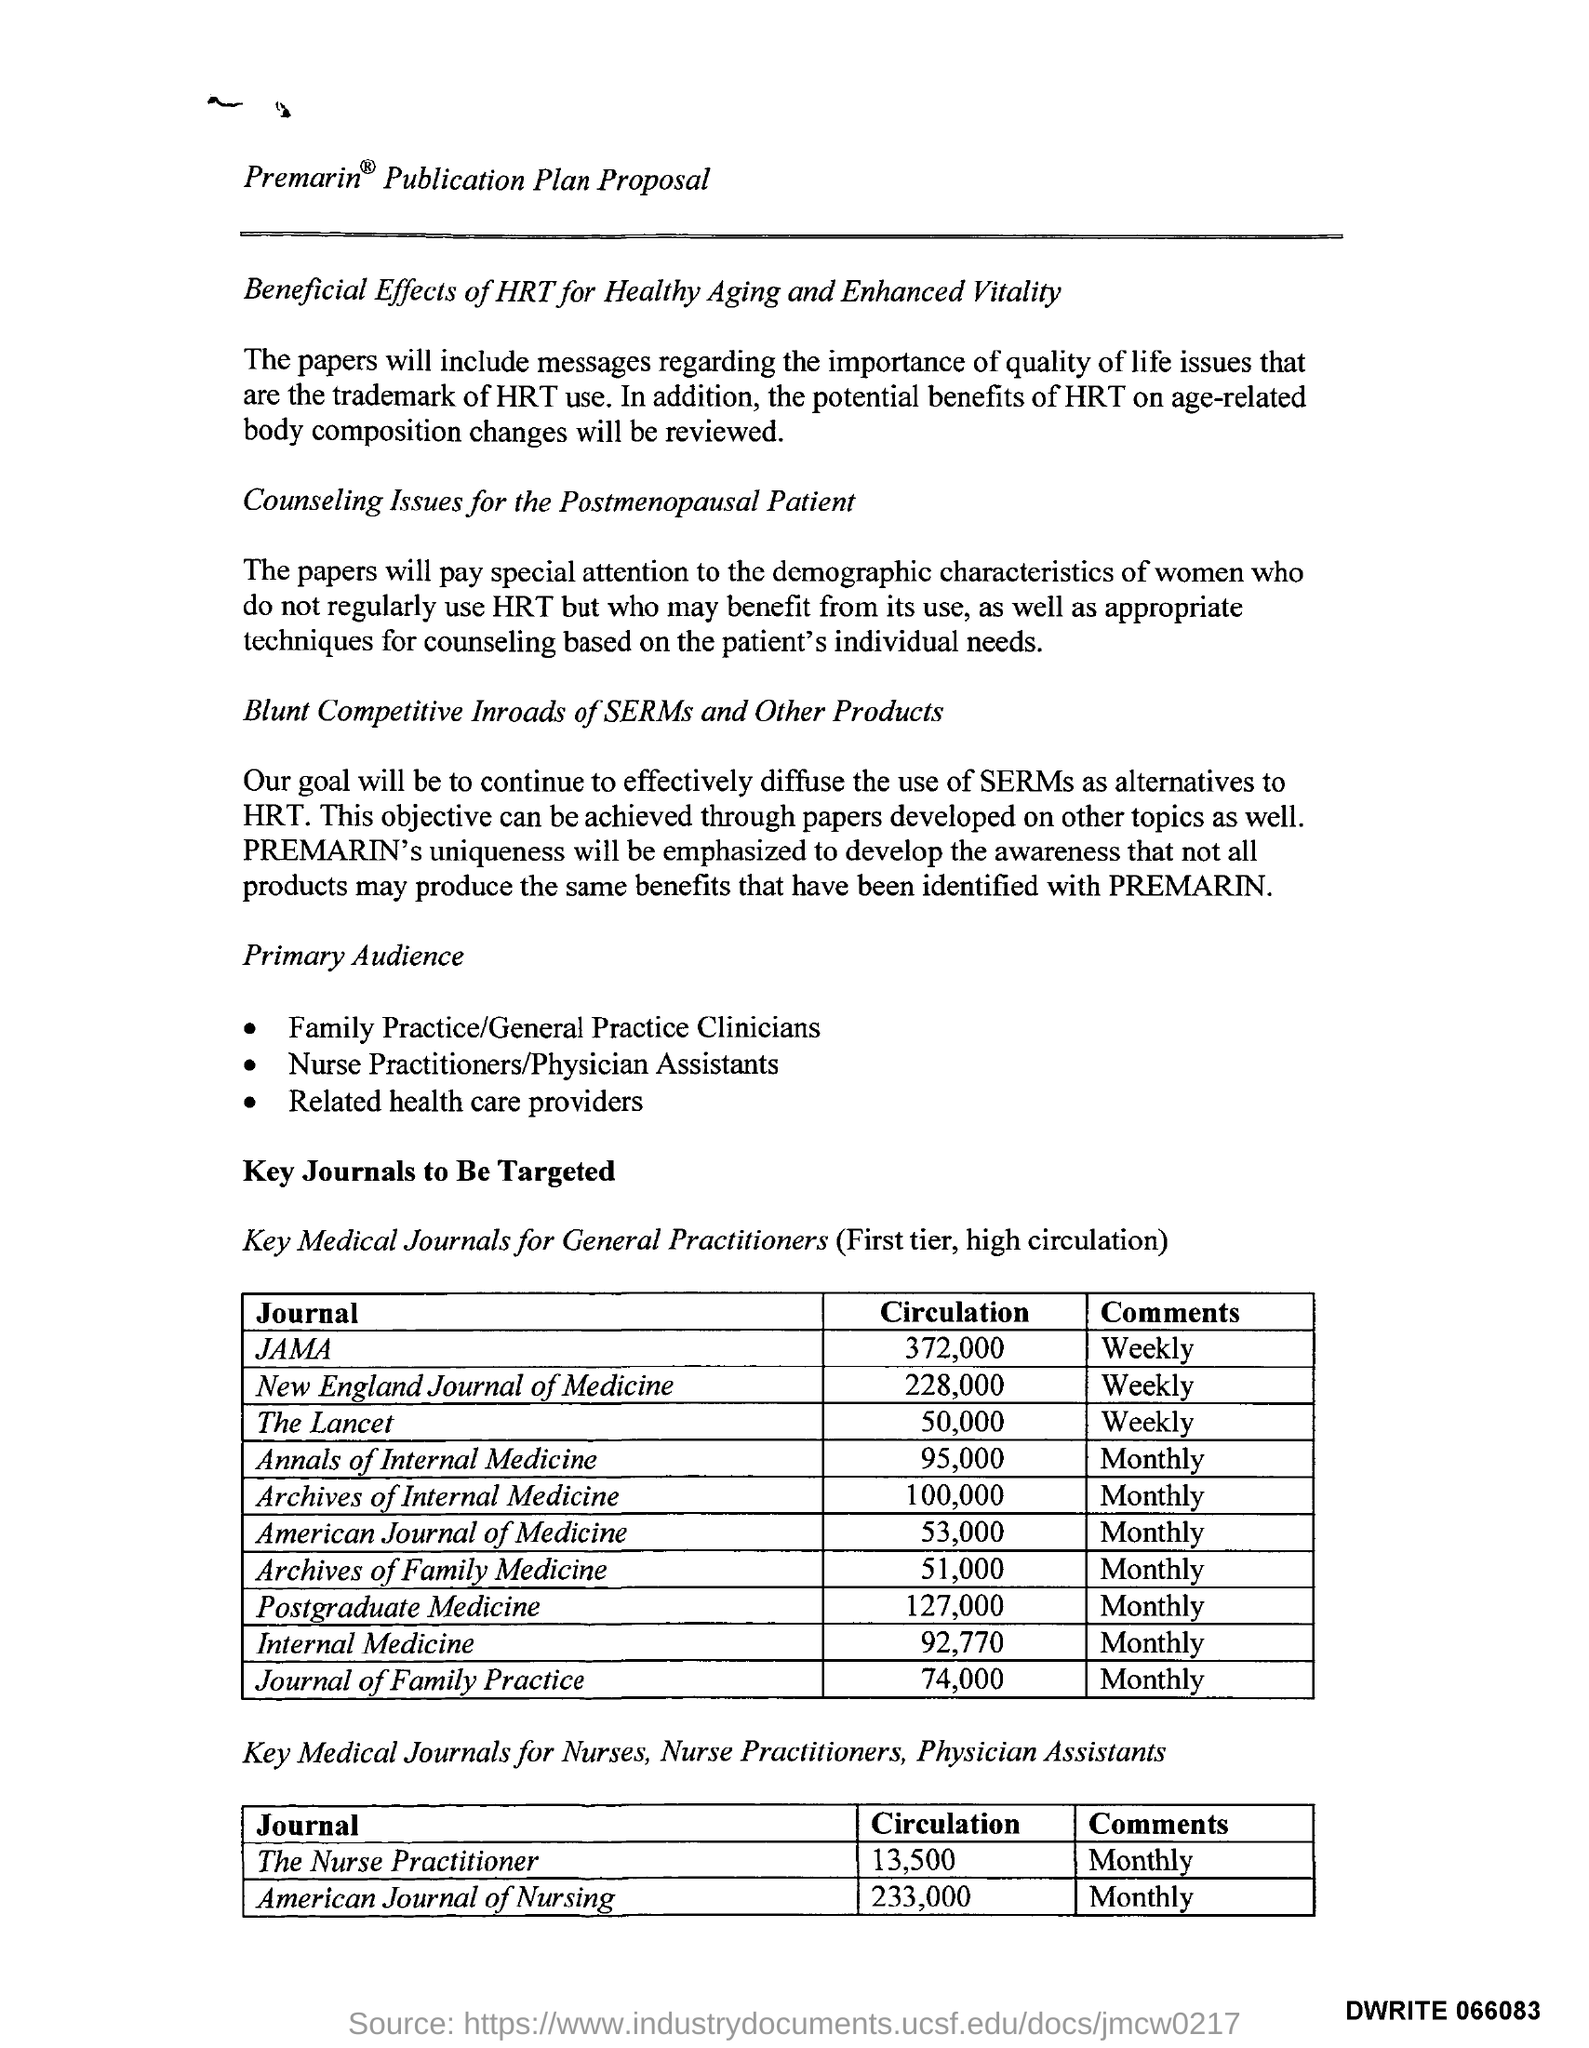Which journal for General Practitioners have the highest circulation?
Your response must be concise. JAMA. 